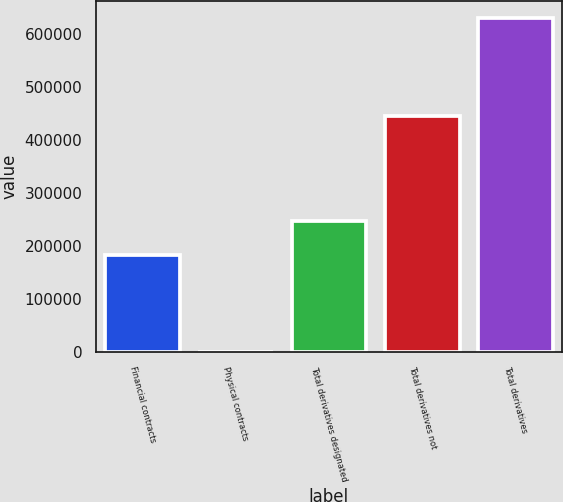<chart> <loc_0><loc_0><loc_500><loc_500><bar_chart><fcel>Financial contracts<fcel>Physical contracts<fcel>Total derivatives designated<fcel>Total derivatives not<fcel>Total derivatives<nl><fcel>184184<fcel>62<fcel>247262<fcel>446601<fcel>630847<nl></chart> 